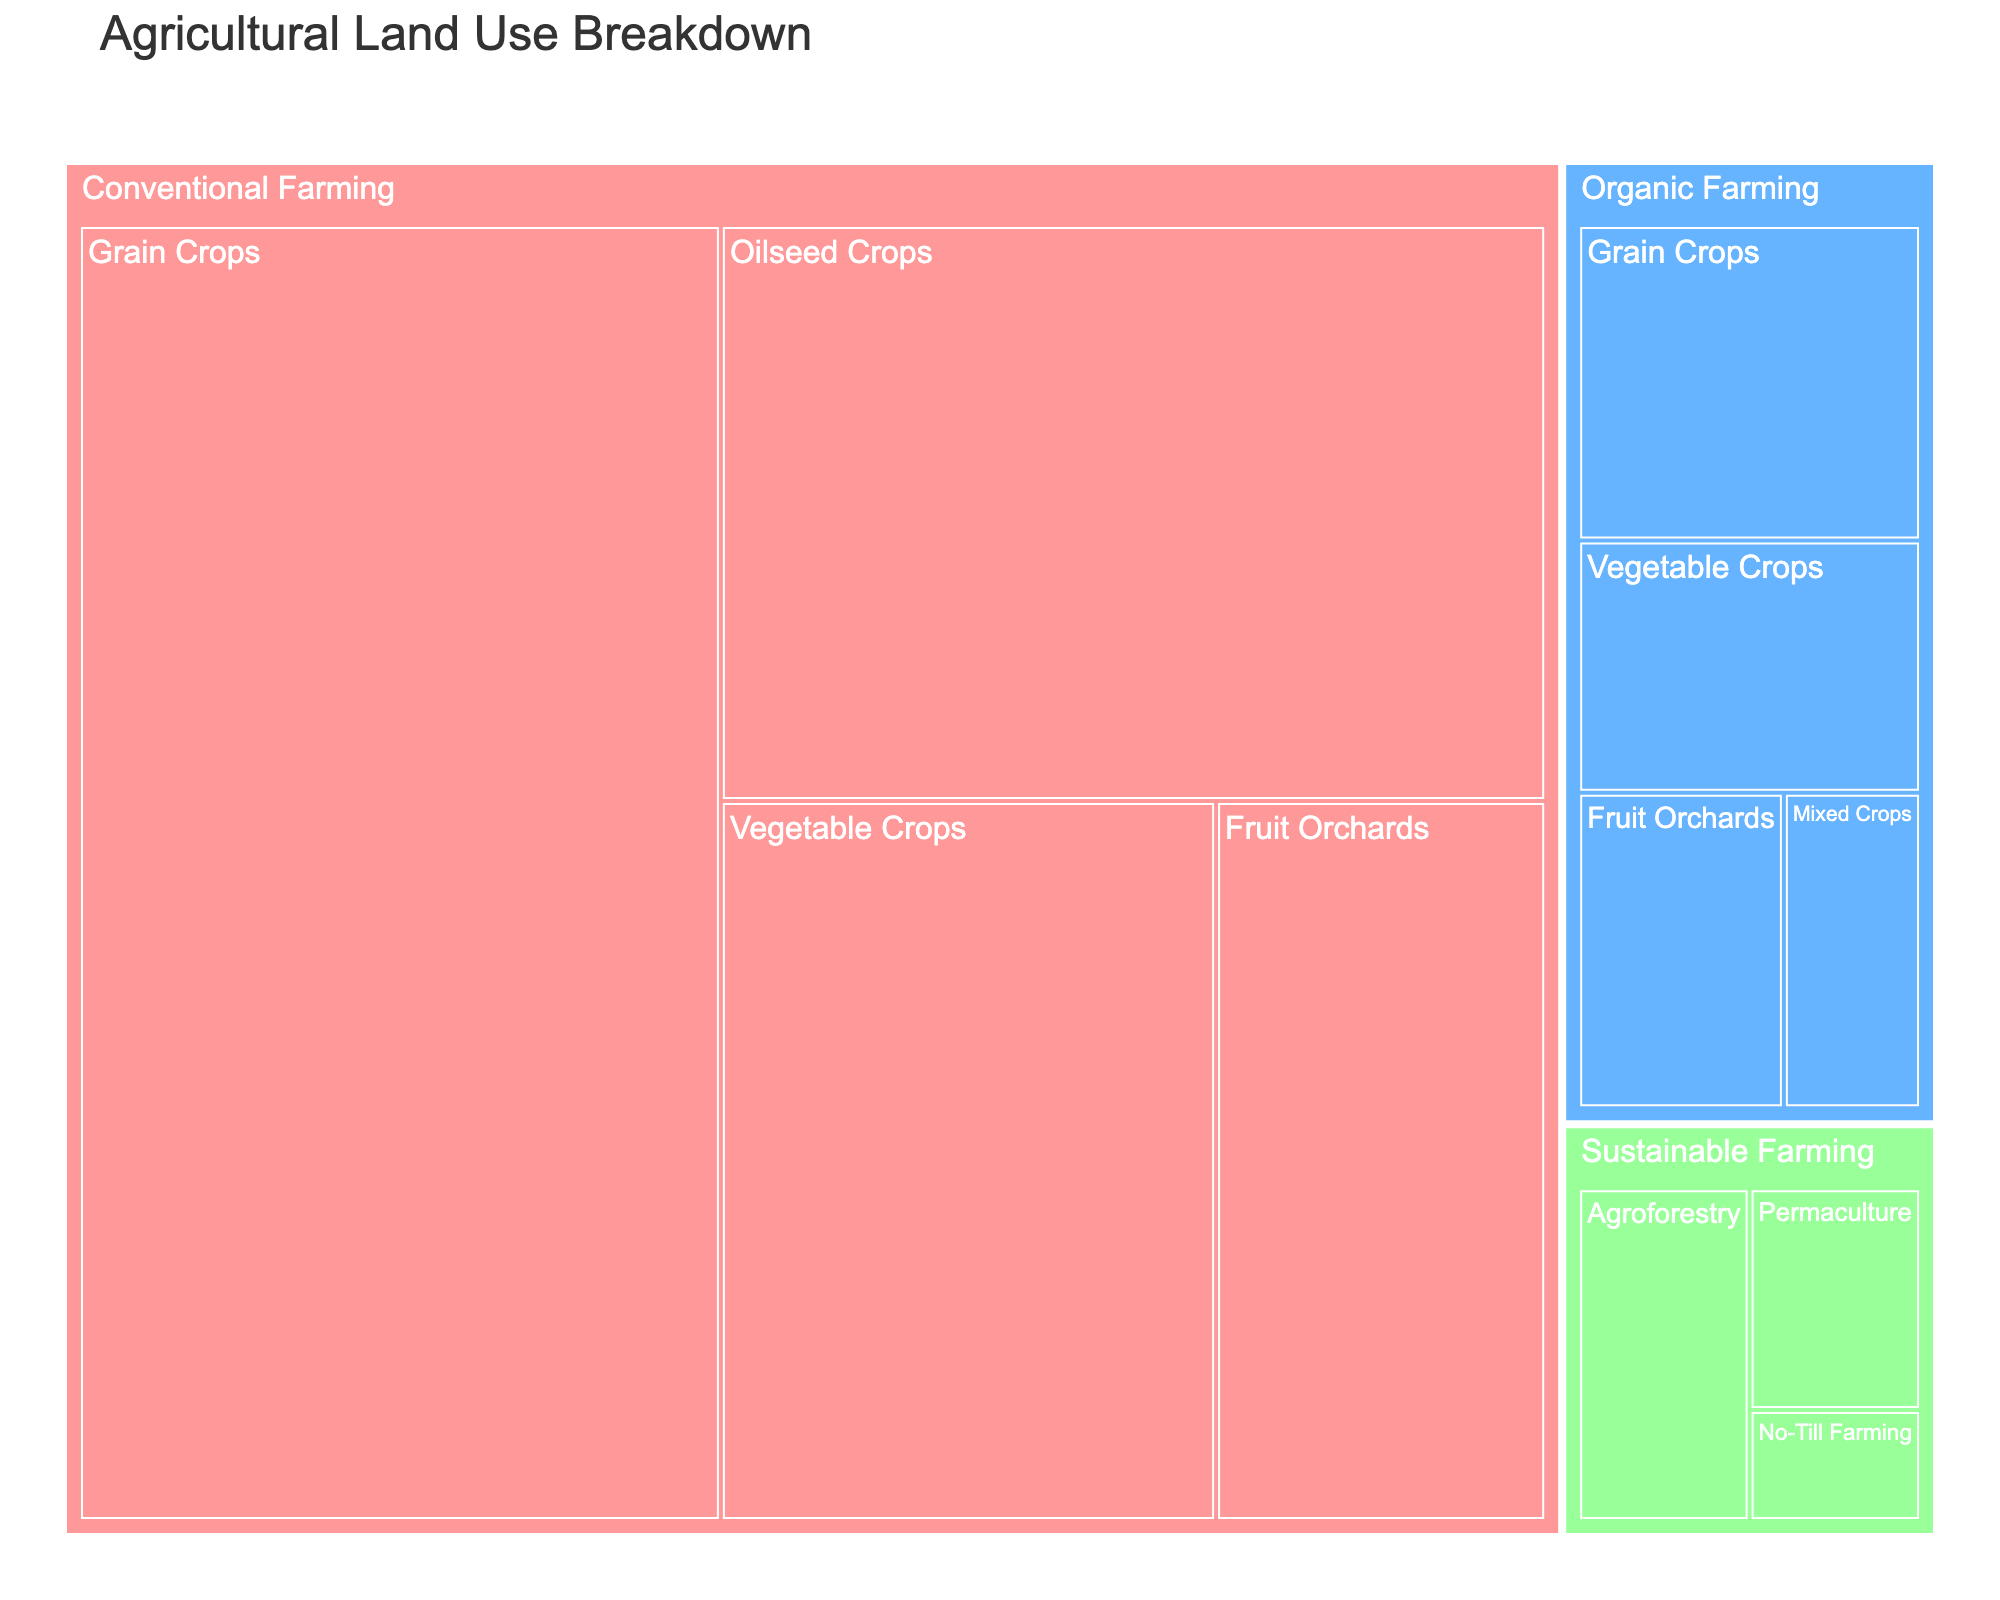What's the title of the treemap? The title can be found at the top of the treemap. It provides a brief description of what the figure represents.
Answer: Agricultural Land Use Breakdown Which farming method uses the largest area for grain crops? The area dedicated to grain crops can be found within the subcategories on the treemap. Look for the largest section under "Grain Crops".
Answer: Conventional Farming How many units of area are used for all types of Organic Farming combined? To find the total area for Organic Farming, sum up the areas of all its subcategories: Grain Crops (5), Vegetable Crops (4), Fruit Orchards (3), and Mixed Crops (2). Therefore, the total is 5 + 4 + 3 + 2 = 14.
Answer: 14 Which category occupies more area: Conventional Farming or both Organic and Sustainable Farming combined? First, sum the areas for Organic and Sustainable Farming (14 + 6 = 20). Now compare this to Conventional Farming's total area (35 + 20 + 15 + 10 = 80).
Answer: Conventional Farming What is the smallest subcategory in Sustainable Farming? Identify the subcategories under Sustainable Farming and compare their areas: Agroforestry (3), Permaculture (2), and No-Till Farming (1). The smallest is No-Till Farming.
Answer: No-Till Farming Which farming method has the minimum total area? Sum the areas for each farming method: Conventional Farming (80), Organic Farming (14), Sustainable Farming (6). The method with the minimum total area is Sustainable Farming.
Answer: Sustainable Farming By how much does the area used for Grain Crops in Conventional Farming exceed that in Organic Farming? Compare the areas: Grain Crops in Conventional Farming (35) and in Organic Farming (5). Calculate the difference: 35 - 5 = 30.
Answer: 30 Among Fruit Orchards, which farming method uses the most area? Compare the areas assigned to Fruit Orchards within each farming method: Conventional Farming (10) and Organic Farming (3). Conventional Farming uses the most area.
Answer: Conventional Farming 